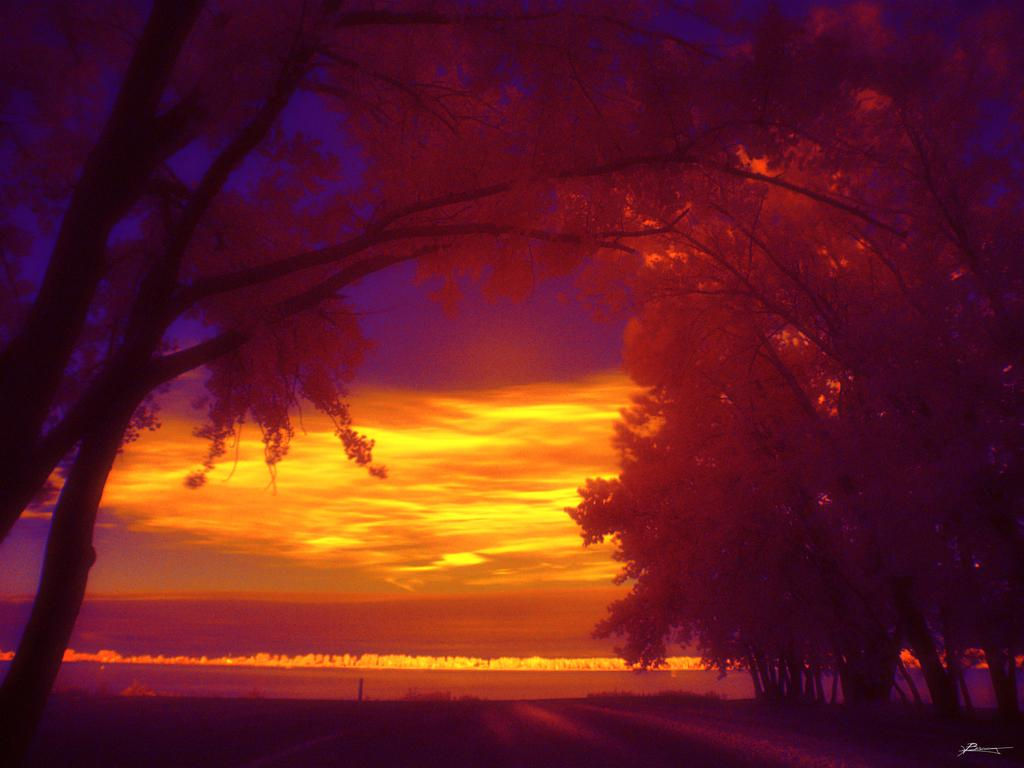What type of vegetation can be seen in the image? There are trees in the image. What part of the natural environment is visible in the image? The sky is visible in the background of the image. What type of iron can be seen in the image? There is no iron present in the image. Is the person's uncle visible in the image? There is no person or uncle mentioned in the image, so we cannot determine if the uncle is present. 